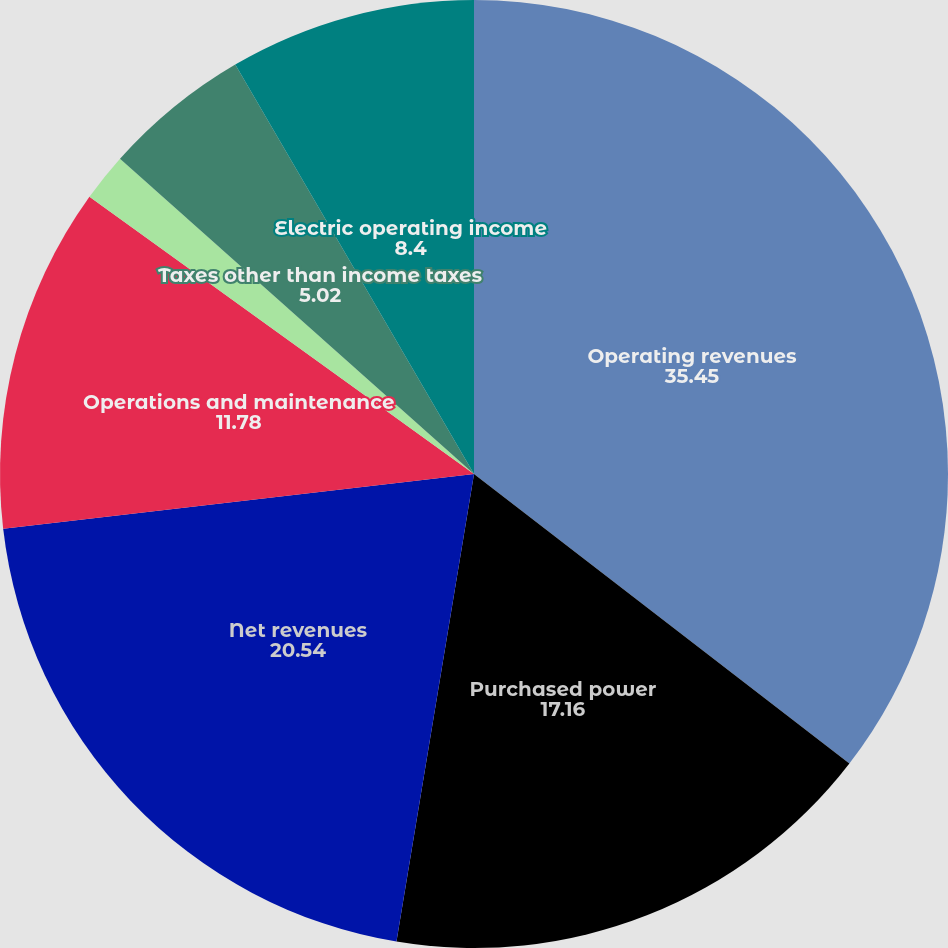Convert chart to OTSL. <chart><loc_0><loc_0><loc_500><loc_500><pie_chart><fcel>Operating revenues<fcel>Purchased power<fcel>Net revenues<fcel>Operations and maintenance<fcel>Depreciation and amortization<fcel>Taxes other than income taxes<fcel>Electric operating income<nl><fcel>35.45%<fcel>17.16%<fcel>20.54%<fcel>11.78%<fcel>1.64%<fcel>5.02%<fcel>8.4%<nl></chart> 